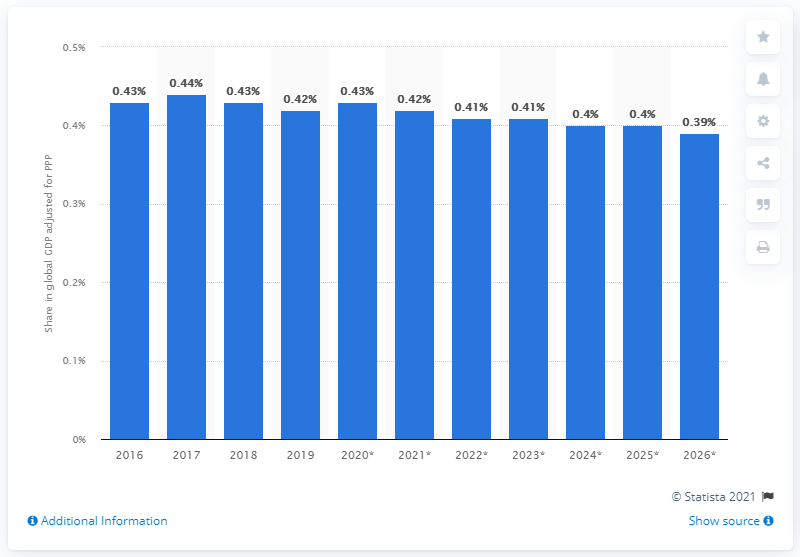Highlight a few significant elements in this photo. According to the data, in 2019, Sweden's share of the global gross domestic product adjusted for Purchasing Power Parity was 0.42. 